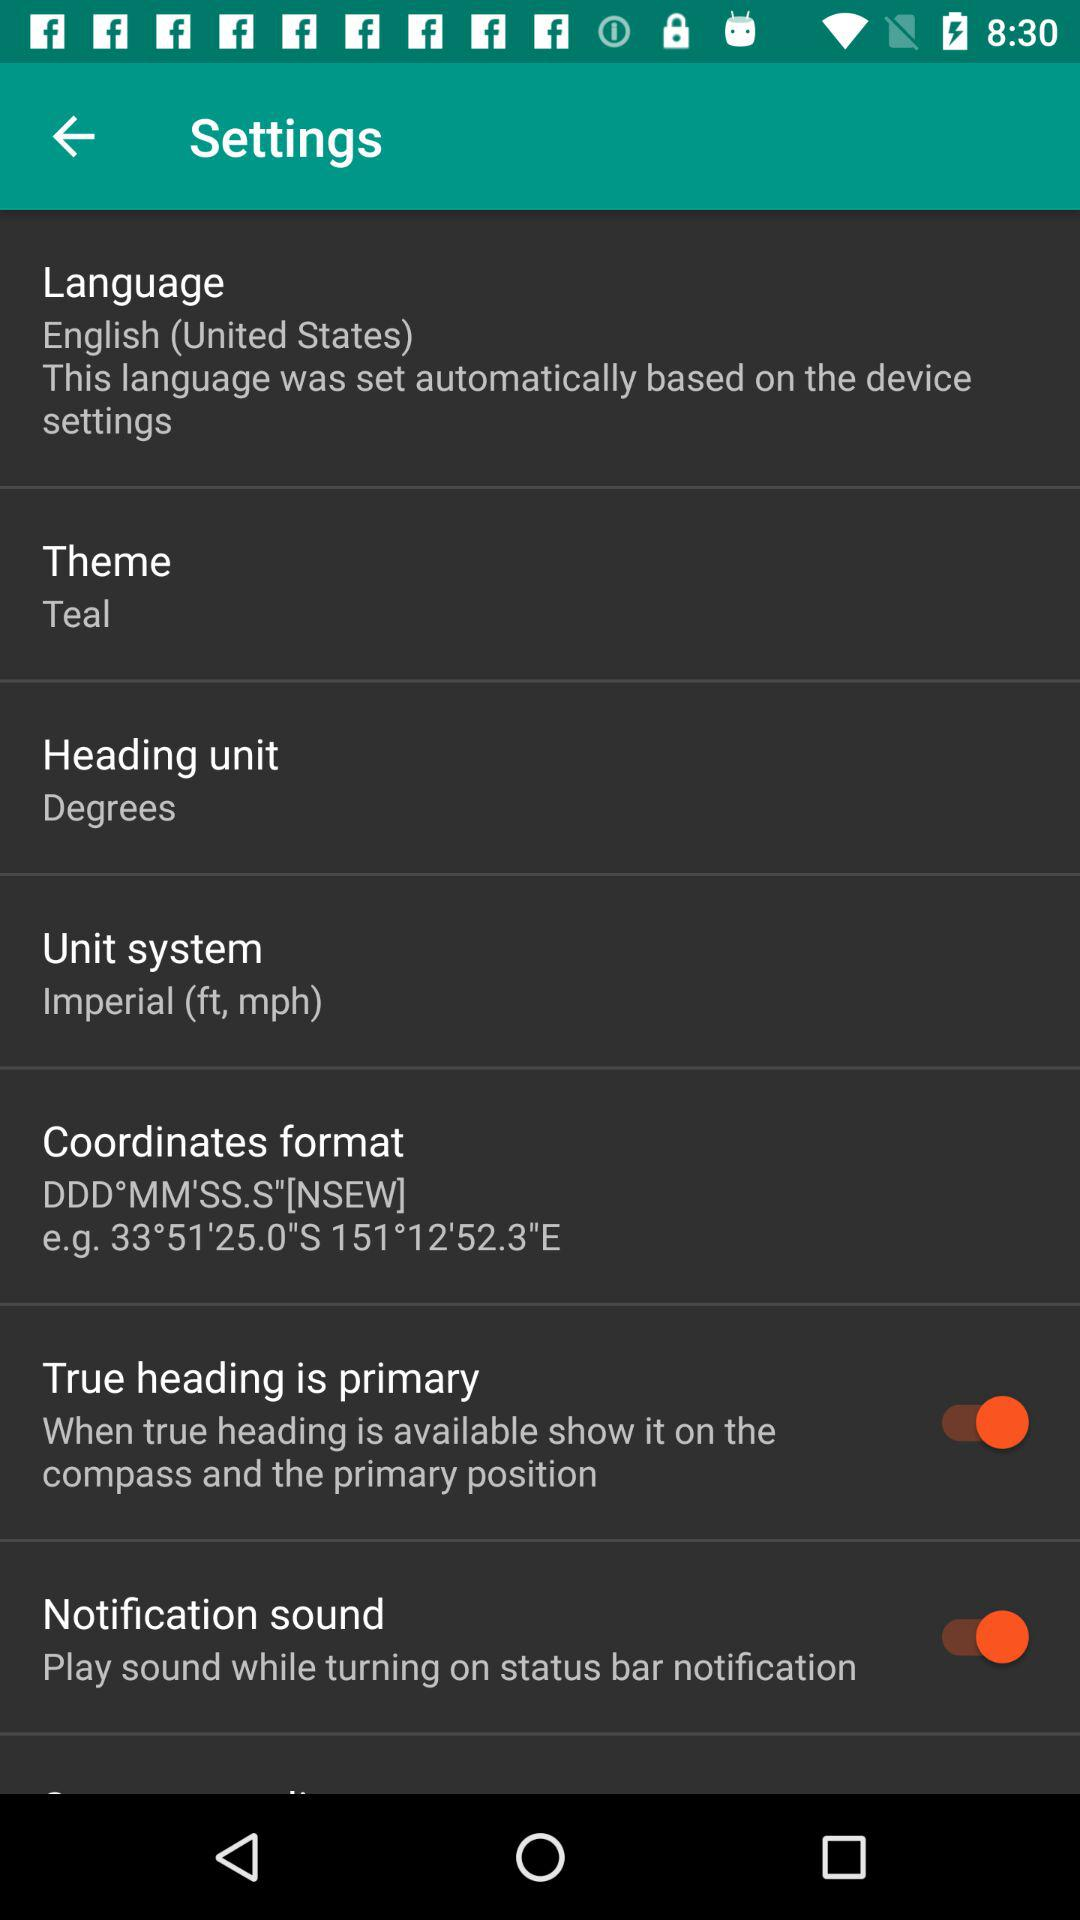What is the current status of the "True heading is primary"? The status is "on". 